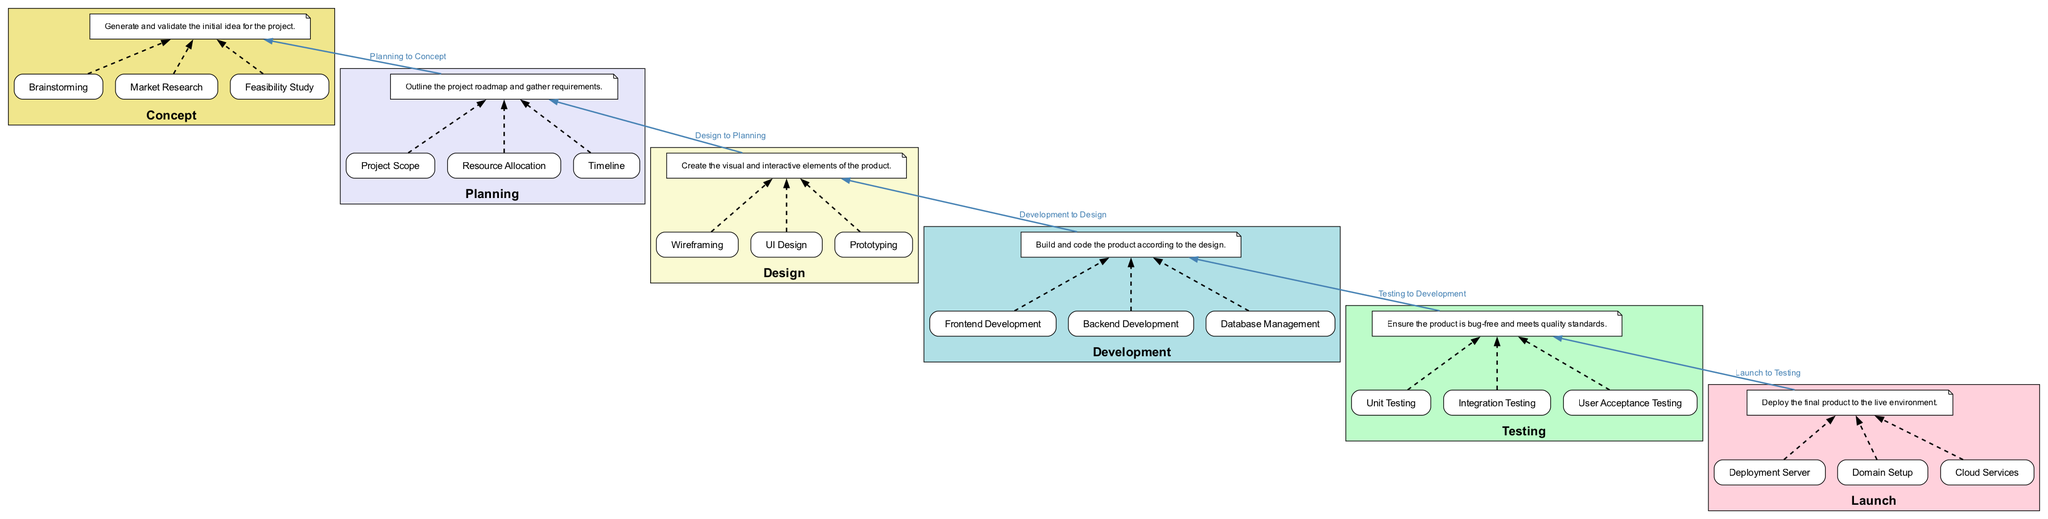What is the final stage in the project pipeline? The last node in the bottom-to-top flow diagram is "Launch", which indicates the final stage of the project pipeline.
Answer: Launch How many stages are present in the project pipeline? There are six stages listed in the diagram: Concept, Planning, Design, Development, Testing, and Launch.
Answer: Six What is the transition between the Testing and Launch stages? The edge that connects the "Testing" stage to the "Launch" stage indicates that the flow progresses from ensuring the product meets quality standards to deploying it. The edge label also confirms this transition.
Answer: Testing to Launch Which entities are involved in the Design stage? The entities associated with the "Design" stage include: Wireframing, UI Design, and Prototyping, as indicated under that stage.
Answer: Wireframing, UI Design, Prototyping What is one major outcome of the Concept stage? The "Concept" stage involves generating and validating initial ideas, as outlined in its description. Thus, a major outcome is the validation of the initial idea for the project.
Answer: Validated Idea What does the arrow between Planning and Design signify? The arrow signifies the flow of the project, showing that once planning is completed, the next logical step is design. This connection indicates the sequential relationship between the two stages.
Answer: Planning to Design How are the entities connected to the Design stage represented? The entities, such as Wireframing, UI Design, and Prototyping, are represented by individual nodes that connect to a description node for the Design stage, allowing viewers to see how they contribute to that stage.
Answer: Description Node Which stage involves user acceptance testing? User Acceptance Testing is specifically mentioned as an entity under the "Testing" stage, indicating that it is part of that process.
Answer: Testing What is the primary focus of the Development stage? The focus of the "Development" stage is on building and coding the product, as outlined in its description.
Answer: Building and Coding 